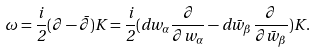Convert formula to latex. <formula><loc_0><loc_0><loc_500><loc_500>\omega = \frac { i } { 2 } ( \partial - \bar { \partial } ) K = \frac { i } { 2 } ( d w _ { \alpha } \frac { \partial } { \partial w _ { \alpha } } - d \bar { w } _ { \beta } \frac { \partial } { \partial \bar { w } _ { \beta } } ) K .</formula> 